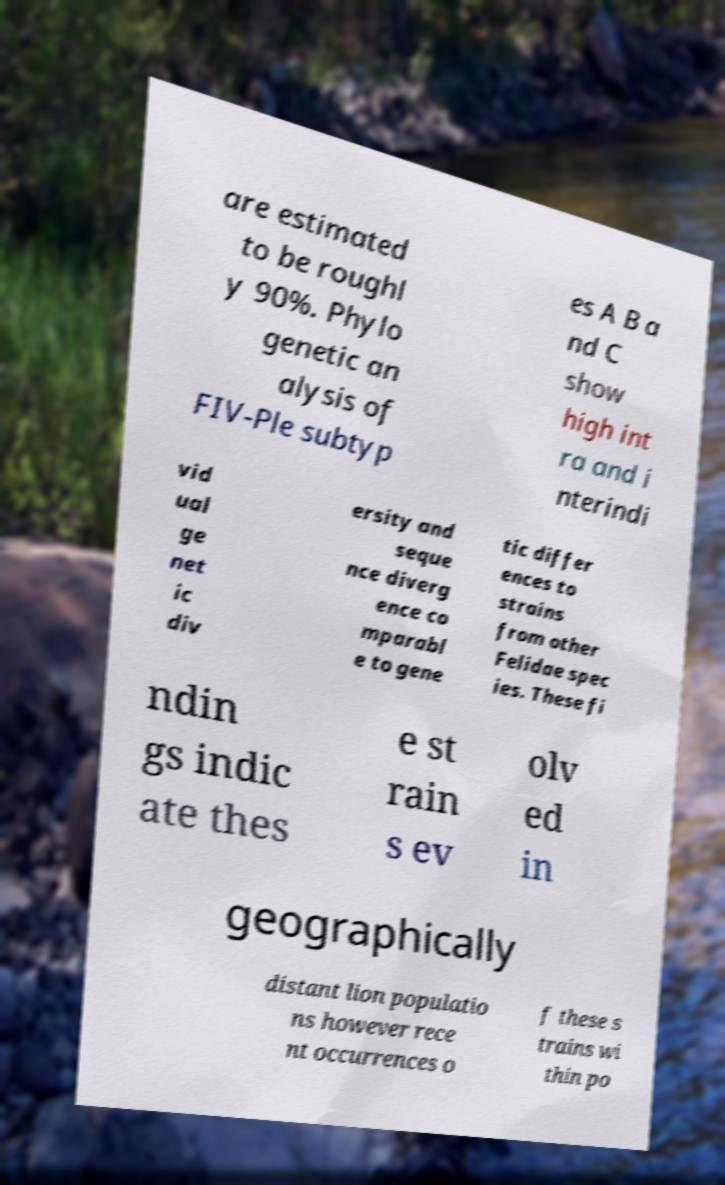Please read and relay the text visible in this image. What does it say? are estimated to be roughl y 90%. Phylo genetic an alysis of FIV-Ple subtyp es A B a nd C show high int ra and i nterindi vid ual ge net ic div ersity and seque nce diverg ence co mparabl e to gene tic differ ences to strains from other Felidae spec ies. These fi ndin gs indic ate thes e st rain s ev olv ed in geographically distant lion populatio ns however rece nt occurrences o f these s trains wi thin po 